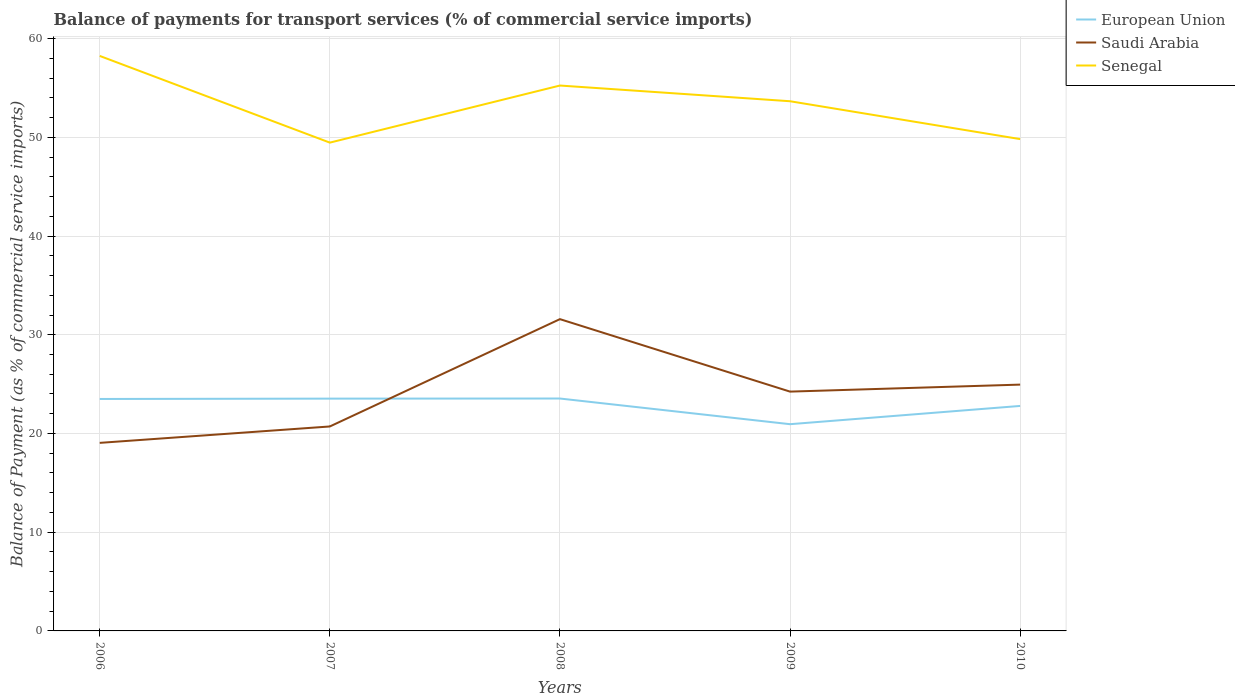Is the number of lines equal to the number of legend labels?
Give a very brief answer. Yes. Across all years, what is the maximum balance of payments for transport services in European Union?
Keep it short and to the point. 20.94. What is the total balance of payments for transport services in Saudi Arabia in the graph?
Your response must be concise. -1.66. What is the difference between the highest and the second highest balance of payments for transport services in Saudi Arabia?
Provide a succinct answer. 12.53. What is the difference between the highest and the lowest balance of payments for transport services in Saudi Arabia?
Ensure brevity in your answer.  3. Is the balance of payments for transport services in Senegal strictly greater than the balance of payments for transport services in Saudi Arabia over the years?
Your answer should be very brief. No. Are the values on the major ticks of Y-axis written in scientific E-notation?
Your response must be concise. No. Does the graph contain grids?
Give a very brief answer. Yes. Where does the legend appear in the graph?
Offer a very short reply. Top right. How many legend labels are there?
Keep it short and to the point. 3. What is the title of the graph?
Provide a succinct answer. Balance of payments for transport services (% of commercial service imports). Does "Haiti" appear as one of the legend labels in the graph?
Your response must be concise. No. What is the label or title of the X-axis?
Give a very brief answer. Years. What is the label or title of the Y-axis?
Provide a succinct answer. Balance of Payment (as % of commercial service imports). What is the Balance of Payment (as % of commercial service imports) of European Union in 2006?
Your answer should be very brief. 23.5. What is the Balance of Payment (as % of commercial service imports) in Saudi Arabia in 2006?
Offer a terse response. 19.05. What is the Balance of Payment (as % of commercial service imports) of Senegal in 2006?
Provide a succinct answer. 58.25. What is the Balance of Payment (as % of commercial service imports) of European Union in 2007?
Your response must be concise. 23.53. What is the Balance of Payment (as % of commercial service imports) of Saudi Arabia in 2007?
Offer a very short reply. 20.71. What is the Balance of Payment (as % of commercial service imports) of Senegal in 2007?
Offer a terse response. 49.46. What is the Balance of Payment (as % of commercial service imports) of European Union in 2008?
Make the answer very short. 23.54. What is the Balance of Payment (as % of commercial service imports) of Saudi Arabia in 2008?
Provide a succinct answer. 31.58. What is the Balance of Payment (as % of commercial service imports) in Senegal in 2008?
Give a very brief answer. 55.25. What is the Balance of Payment (as % of commercial service imports) of European Union in 2009?
Ensure brevity in your answer.  20.94. What is the Balance of Payment (as % of commercial service imports) in Saudi Arabia in 2009?
Ensure brevity in your answer.  24.24. What is the Balance of Payment (as % of commercial service imports) of Senegal in 2009?
Keep it short and to the point. 53.65. What is the Balance of Payment (as % of commercial service imports) in European Union in 2010?
Offer a terse response. 22.79. What is the Balance of Payment (as % of commercial service imports) in Saudi Arabia in 2010?
Your answer should be very brief. 24.95. What is the Balance of Payment (as % of commercial service imports) of Senegal in 2010?
Keep it short and to the point. 49.82. Across all years, what is the maximum Balance of Payment (as % of commercial service imports) of European Union?
Make the answer very short. 23.54. Across all years, what is the maximum Balance of Payment (as % of commercial service imports) in Saudi Arabia?
Ensure brevity in your answer.  31.58. Across all years, what is the maximum Balance of Payment (as % of commercial service imports) in Senegal?
Provide a succinct answer. 58.25. Across all years, what is the minimum Balance of Payment (as % of commercial service imports) in European Union?
Give a very brief answer. 20.94. Across all years, what is the minimum Balance of Payment (as % of commercial service imports) of Saudi Arabia?
Make the answer very short. 19.05. Across all years, what is the minimum Balance of Payment (as % of commercial service imports) in Senegal?
Keep it short and to the point. 49.46. What is the total Balance of Payment (as % of commercial service imports) of European Union in the graph?
Offer a very short reply. 114.3. What is the total Balance of Payment (as % of commercial service imports) in Saudi Arabia in the graph?
Your answer should be compact. 120.53. What is the total Balance of Payment (as % of commercial service imports) of Senegal in the graph?
Your response must be concise. 266.43. What is the difference between the Balance of Payment (as % of commercial service imports) of European Union in 2006 and that in 2007?
Provide a short and direct response. -0.04. What is the difference between the Balance of Payment (as % of commercial service imports) in Saudi Arabia in 2006 and that in 2007?
Keep it short and to the point. -1.66. What is the difference between the Balance of Payment (as % of commercial service imports) of Senegal in 2006 and that in 2007?
Your answer should be compact. 8.78. What is the difference between the Balance of Payment (as % of commercial service imports) in European Union in 2006 and that in 2008?
Your response must be concise. -0.05. What is the difference between the Balance of Payment (as % of commercial service imports) of Saudi Arabia in 2006 and that in 2008?
Keep it short and to the point. -12.53. What is the difference between the Balance of Payment (as % of commercial service imports) in Senegal in 2006 and that in 2008?
Provide a short and direct response. 3. What is the difference between the Balance of Payment (as % of commercial service imports) of European Union in 2006 and that in 2009?
Give a very brief answer. 2.55. What is the difference between the Balance of Payment (as % of commercial service imports) in Saudi Arabia in 2006 and that in 2009?
Offer a very short reply. -5.19. What is the difference between the Balance of Payment (as % of commercial service imports) in Senegal in 2006 and that in 2009?
Offer a terse response. 4.59. What is the difference between the Balance of Payment (as % of commercial service imports) of European Union in 2006 and that in 2010?
Keep it short and to the point. 0.71. What is the difference between the Balance of Payment (as % of commercial service imports) in Saudi Arabia in 2006 and that in 2010?
Provide a succinct answer. -5.9. What is the difference between the Balance of Payment (as % of commercial service imports) in Senegal in 2006 and that in 2010?
Keep it short and to the point. 8.43. What is the difference between the Balance of Payment (as % of commercial service imports) in European Union in 2007 and that in 2008?
Offer a terse response. -0.01. What is the difference between the Balance of Payment (as % of commercial service imports) of Saudi Arabia in 2007 and that in 2008?
Give a very brief answer. -10.87. What is the difference between the Balance of Payment (as % of commercial service imports) of Senegal in 2007 and that in 2008?
Offer a terse response. -5.78. What is the difference between the Balance of Payment (as % of commercial service imports) of European Union in 2007 and that in 2009?
Your answer should be very brief. 2.59. What is the difference between the Balance of Payment (as % of commercial service imports) of Saudi Arabia in 2007 and that in 2009?
Provide a short and direct response. -3.53. What is the difference between the Balance of Payment (as % of commercial service imports) in Senegal in 2007 and that in 2009?
Make the answer very short. -4.19. What is the difference between the Balance of Payment (as % of commercial service imports) of European Union in 2007 and that in 2010?
Offer a terse response. 0.74. What is the difference between the Balance of Payment (as % of commercial service imports) in Saudi Arabia in 2007 and that in 2010?
Make the answer very short. -4.24. What is the difference between the Balance of Payment (as % of commercial service imports) in Senegal in 2007 and that in 2010?
Your answer should be compact. -0.36. What is the difference between the Balance of Payment (as % of commercial service imports) in European Union in 2008 and that in 2009?
Your response must be concise. 2.6. What is the difference between the Balance of Payment (as % of commercial service imports) of Saudi Arabia in 2008 and that in 2009?
Ensure brevity in your answer.  7.34. What is the difference between the Balance of Payment (as % of commercial service imports) of Senegal in 2008 and that in 2009?
Your answer should be very brief. 1.59. What is the difference between the Balance of Payment (as % of commercial service imports) of European Union in 2008 and that in 2010?
Provide a short and direct response. 0.75. What is the difference between the Balance of Payment (as % of commercial service imports) in Saudi Arabia in 2008 and that in 2010?
Make the answer very short. 6.63. What is the difference between the Balance of Payment (as % of commercial service imports) of Senegal in 2008 and that in 2010?
Your answer should be compact. 5.43. What is the difference between the Balance of Payment (as % of commercial service imports) of European Union in 2009 and that in 2010?
Offer a very short reply. -1.85. What is the difference between the Balance of Payment (as % of commercial service imports) in Saudi Arabia in 2009 and that in 2010?
Make the answer very short. -0.71. What is the difference between the Balance of Payment (as % of commercial service imports) of Senegal in 2009 and that in 2010?
Your response must be concise. 3.84. What is the difference between the Balance of Payment (as % of commercial service imports) of European Union in 2006 and the Balance of Payment (as % of commercial service imports) of Saudi Arabia in 2007?
Offer a very short reply. 2.79. What is the difference between the Balance of Payment (as % of commercial service imports) of European Union in 2006 and the Balance of Payment (as % of commercial service imports) of Senegal in 2007?
Make the answer very short. -25.97. What is the difference between the Balance of Payment (as % of commercial service imports) of Saudi Arabia in 2006 and the Balance of Payment (as % of commercial service imports) of Senegal in 2007?
Provide a short and direct response. -30.41. What is the difference between the Balance of Payment (as % of commercial service imports) of European Union in 2006 and the Balance of Payment (as % of commercial service imports) of Saudi Arabia in 2008?
Provide a succinct answer. -8.09. What is the difference between the Balance of Payment (as % of commercial service imports) in European Union in 2006 and the Balance of Payment (as % of commercial service imports) in Senegal in 2008?
Offer a very short reply. -31.75. What is the difference between the Balance of Payment (as % of commercial service imports) in Saudi Arabia in 2006 and the Balance of Payment (as % of commercial service imports) in Senegal in 2008?
Make the answer very short. -36.2. What is the difference between the Balance of Payment (as % of commercial service imports) of European Union in 2006 and the Balance of Payment (as % of commercial service imports) of Saudi Arabia in 2009?
Provide a short and direct response. -0.75. What is the difference between the Balance of Payment (as % of commercial service imports) in European Union in 2006 and the Balance of Payment (as % of commercial service imports) in Senegal in 2009?
Keep it short and to the point. -30.16. What is the difference between the Balance of Payment (as % of commercial service imports) of Saudi Arabia in 2006 and the Balance of Payment (as % of commercial service imports) of Senegal in 2009?
Provide a succinct answer. -34.61. What is the difference between the Balance of Payment (as % of commercial service imports) in European Union in 2006 and the Balance of Payment (as % of commercial service imports) in Saudi Arabia in 2010?
Offer a very short reply. -1.45. What is the difference between the Balance of Payment (as % of commercial service imports) in European Union in 2006 and the Balance of Payment (as % of commercial service imports) in Senegal in 2010?
Ensure brevity in your answer.  -26.32. What is the difference between the Balance of Payment (as % of commercial service imports) of Saudi Arabia in 2006 and the Balance of Payment (as % of commercial service imports) of Senegal in 2010?
Provide a succinct answer. -30.77. What is the difference between the Balance of Payment (as % of commercial service imports) in European Union in 2007 and the Balance of Payment (as % of commercial service imports) in Saudi Arabia in 2008?
Provide a short and direct response. -8.05. What is the difference between the Balance of Payment (as % of commercial service imports) in European Union in 2007 and the Balance of Payment (as % of commercial service imports) in Senegal in 2008?
Provide a succinct answer. -31.71. What is the difference between the Balance of Payment (as % of commercial service imports) in Saudi Arabia in 2007 and the Balance of Payment (as % of commercial service imports) in Senegal in 2008?
Offer a terse response. -34.54. What is the difference between the Balance of Payment (as % of commercial service imports) in European Union in 2007 and the Balance of Payment (as % of commercial service imports) in Saudi Arabia in 2009?
Your answer should be compact. -0.71. What is the difference between the Balance of Payment (as % of commercial service imports) of European Union in 2007 and the Balance of Payment (as % of commercial service imports) of Senegal in 2009?
Provide a succinct answer. -30.12. What is the difference between the Balance of Payment (as % of commercial service imports) of Saudi Arabia in 2007 and the Balance of Payment (as % of commercial service imports) of Senegal in 2009?
Make the answer very short. -32.94. What is the difference between the Balance of Payment (as % of commercial service imports) of European Union in 2007 and the Balance of Payment (as % of commercial service imports) of Saudi Arabia in 2010?
Provide a short and direct response. -1.42. What is the difference between the Balance of Payment (as % of commercial service imports) of European Union in 2007 and the Balance of Payment (as % of commercial service imports) of Senegal in 2010?
Your answer should be very brief. -26.29. What is the difference between the Balance of Payment (as % of commercial service imports) in Saudi Arabia in 2007 and the Balance of Payment (as % of commercial service imports) in Senegal in 2010?
Keep it short and to the point. -29.11. What is the difference between the Balance of Payment (as % of commercial service imports) in European Union in 2008 and the Balance of Payment (as % of commercial service imports) in Saudi Arabia in 2009?
Give a very brief answer. -0.7. What is the difference between the Balance of Payment (as % of commercial service imports) in European Union in 2008 and the Balance of Payment (as % of commercial service imports) in Senegal in 2009?
Make the answer very short. -30.11. What is the difference between the Balance of Payment (as % of commercial service imports) in Saudi Arabia in 2008 and the Balance of Payment (as % of commercial service imports) in Senegal in 2009?
Your answer should be compact. -22.07. What is the difference between the Balance of Payment (as % of commercial service imports) of European Union in 2008 and the Balance of Payment (as % of commercial service imports) of Saudi Arabia in 2010?
Your answer should be compact. -1.41. What is the difference between the Balance of Payment (as % of commercial service imports) of European Union in 2008 and the Balance of Payment (as % of commercial service imports) of Senegal in 2010?
Your response must be concise. -26.28. What is the difference between the Balance of Payment (as % of commercial service imports) of Saudi Arabia in 2008 and the Balance of Payment (as % of commercial service imports) of Senegal in 2010?
Provide a short and direct response. -18.24. What is the difference between the Balance of Payment (as % of commercial service imports) in European Union in 2009 and the Balance of Payment (as % of commercial service imports) in Saudi Arabia in 2010?
Offer a terse response. -4.01. What is the difference between the Balance of Payment (as % of commercial service imports) of European Union in 2009 and the Balance of Payment (as % of commercial service imports) of Senegal in 2010?
Your response must be concise. -28.88. What is the difference between the Balance of Payment (as % of commercial service imports) in Saudi Arabia in 2009 and the Balance of Payment (as % of commercial service imports) in Senegal in 2010?
Make the answer very short. -25.58. What is the average Balance of Payment (as % of commercial service imports) in European Union per year?
Offer a terse response. 22.86. What is the average Balance of Payment (as % of commercial service imports) in Saudi Arabia per year?
Provide a succinct answer. 24.11. What is the average Balance of Payment (as % of commercial service imports) in Senegal per year?
Your answer should be compact. 53.29. In the year 2006, what is the difference between the Balance of Payment (as % of commercial service imports) in European Union and Balance of Payment (as % of commercial service imports) in Saudi Arabia?
Make the answer very short. 4.45. In the year 2006, what is the difference between the Balance of Payment (as % of commercial service imports) in European Union and Balance of Payment (as % of commercial service imports) in Senegal?
Offer a very short reply. -34.75. In the year 2006, what is the difference between the Balance of Payment (as % of commercial service imports) of Saudi Arabia and Balance of Payment (as % of commercial service imports) of Senegal?
Keep it short and to the point. -39.2. In the year 2007, what is the difference between the Balance of Payment (as % of commercial service imports) of European Union and Balance of Payment (as % of commercial service imports) of Saudi Arabia?
Your answer should be very brief. 2.82. In the year 2007, what is the difference between the Balance of Payment (as % of commercial service imports) in European Union and Balance of Payment (as % of commercial service imports) in Senegal?
Offer a very short reply. -25.93. In the year 2007, what is the difference between the Balance of Payment (as % of commercial service imports) in Saudi Arabia and Balance of Payment (as % of commercial service imports) in Senegal?
Your response must be concise. -28.75. In the year 2008, what is the difference between the Balance of Payment (as % of commercial service imports) of European Union and Balance of Payment (as % of commercial service imports) of Saudi Arabia?
Provide a succinct answer. -8.04. In the year 2008, what is the difference between the Balance of Payment (as % of commercial service imports) of European Union and Balance of Payment (as % of commercial service imports) of Senegal?
Provide a short and direct response. -31.7. In the year 2008, what is the difference between the Balance of Payment (as % of commercial service imports) of Saudi Arabia and Balance of Payment (as % of commercial service imports) of Senegal?
Your answer should be very brief. -23.66. In the year 2009, what is the difference between the Balance of Payment (as % of commercial service imports) in European Union and Balance of Payment (as % of commercial service imports) in Saudi Arabia?
Your answer should be very brief. -3.3. In the year 2009, what is the difference between the Balance of Payment (as % of commercial service imports) of European Union and Balance of Payment (as % of commercial service imports) of Senegal?
Ensure brevity in your answer.  -32.71. In the year 2009, what is the difference between the Balance of Payment (as % of commercial service imports) in Saudi Arabia and Balance of Payment (as % of commercial service imports) in Senegal?
Ensure brevity in your answer.  -29.41. In the year 2010, what is the difference between the Balance of Payment (as % of commercial service imports) in European Union and Balance of Payment (as % of commercial service imports) in Saudi Arabia?
Provide a short and direct response. -2.16. In the year 2010, what is the difference between the Balance of Payment (as % of commercial service imports) of European Union and Balance of Payment (as % of commercial service imports) of Senegal?
Give a very brief answer. -27.03. In the year 2010, what is the difference between the Balance of Payment (as % of commercial service imports) of Saudi Arabia and Balance of Payment (as % of commercial service imports) of Senegal?
Keep it short and to the point. -24.87. What is the ratio of the Balance of Payment (as % of commercial service imports) in European Union in 2006 to that in 2007?
Offer a very short reply. 1. What is the ratio of the Balance of Payment (as % of commercial service imports) in Saudi Arabia in 2006 to that in 2007?
Give a very brief answer. 0.92. What is the ratio of the Balance of Payment (as % of commercial service imports) of Senegal in 2006 to that in 2007?
Offer a terse response. 1.18. What is the ratio of the Balance of Payment (as % of commercial service imports) in Saudi Arabia in 2006 to that in 2008?
Ensure brevity in your answer.  0.6. What is the ratio of the Balance of Payment (as % of commercial service imports) in Senegal in 2006 to that in 2008?
Your response must be concise. 1.05. What is the ratio of the Balance of Payment (as % of commercial service imports) of European Union in 2006 to that in 2009?
Provide a short and direct response. 1.12. What is the ratio of the Balance of Payment (as % of commercial service imports) in Saudi Arabia in 2006 to that in 2009?
Ensure brevity in your answer.  0.79. What is the ratio of the Balance of Payment (as % of commercial service imports) in Senegal in 2006 to that in 2009?
Your answer should be compact. 1.09. What is the ratio of the Balance of Payment (as % of commercial service imports) in European Union in 2006 to that in 2010?
Give a very brief answer. 1.03. What is the ratio of the Balance of Payment (as % of commercial service imports) in Saudi Arabia in 2006 to that in 2010?
Keep it short and to the point. 0.76. What is the ratio of the Balance of Payment (as % of commercial service imports) in Senegal in 2006 to that in 2010?
Provide a short and direct response. 1.17. What is the ratio of the Balance of Payment (as % of commercial service imports) of Saudi Arabia in 2007 to that in 2008?
Your answer should be very brief. 0.66. What is the ratio of the Balance of Payment (as % of commercial service imports) in Senegal in 2007 to that in 2008?
Keep it short and to the point. 0.9. What is the ratio of the Balance of Payment (as % of commercial service imports) of European Union in 2007 to that in 2009?
Provide a succinct answer. 1.12. What is the ratio of the Balance of Payment (as % of commercial service imports) in Saudi Arabia in 2007 to that in 2009?
Provide a succinct answer. 0.85. What is the ratio of the Balance of Payment (as % of commercial service imports) of Senegal in 2007 to that in 2009?
Give a very brief answer. 0.92. What is the ratio of the Balance of Payment (as % of commercial service imports) in European Union in 2007 to that in 2010?
Offer a terse response. 1.03. What is the ratio of the Balance of Payment (as % of commercial service imports) of Saudi Arabia in 2007 to that in 2010?
Offer a terse response. 0.83. What is the ratio of the Balance of Payment (as % of commercial service imports) in Senegal in 2007 to that in 2010?
Provide a succinct answer. 0.99. What is the ratio of the Balance of Payment (as % of commercial service imports) of European Union in 2008 to that in 2009?
Offer a very short reply. 1.12. What is the ratio of the Balance of Payment (as % of commercial service imports) of Saudi Arabia in 2008 to that in 2009?
Give a very brief answer. 1.3. What is the ratio of the Balance of Payment (as % of commercial service imports) in Senegal in 2008 to that in 2009?
Your answer should be very brief. 1.03. What is the ratio of the Balance of Payment (as % of commercial service imports) in European Union in 2008 to that in 2010?
Keep it short and to the point. 1.03. What is the ratio of the Balance of Payment (as % of commercial service imports) of Saudi Arabia in 2008 to that in 2010?
Make the answer very short. 1.27. What is the ratio of the Balance of Payment (as % of commercial service imports) of Senegal in 2008 to that in 2010?
Give a very brief answer. 1.11. What is the ratio of the Balance of Payment (as % of commercial service imports) of European Union in 2009 to that in 2010?
Provide a succinct answer. 0.92. What is the ratio of the Balance of Payment (as % of commercial service imports) of Saudi Arabia in 2009 to that in 2010?
Offer a terse response. 0.97. What is the ratio of the Balance of Payment (as % of commercial service imports) of Senegal in 2009 to that in 2010?
Provide a succinct answer. 1.08. What is the difference between the highest and the second highest Balance of Payment (as % of commercial service imports) of European Union?
Provide a short and direct response. 0.01. What is the difference between the highest and the second highest Balance of Payment (as % of commercial service imports) of Saudi Arabia?
Provide a short and direct response. 6.63. What is the difference between the highest and the second highest Balance of Payment (as % of commercial service imports) of Senegal?
Offer a terse response. 3. What is the difference between the highest and the lowest Balance of Payment (as % of commercial service imports) in European Union?
Offer a very short reply. 2.6. What is the difference between the highest and the lowest Balance of Payment (as % of commercial service imports) in Saudi Arabia?
Ensure brevity in your answer.  12.53. What is the difference between the highest and the lowest Balance of Payment (as % of commercial service imports) in Senegal?
Offer a terse response. 8.78. 